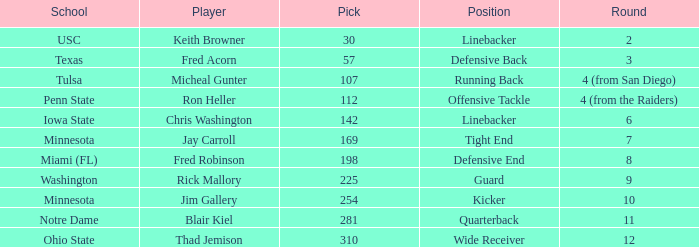What is the pick number of Penn State? 112.0. 